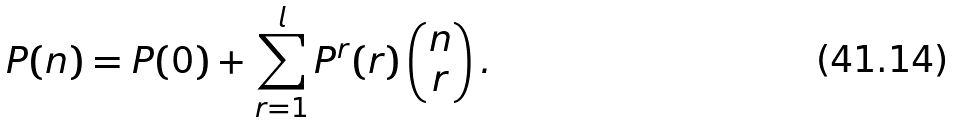Convert formula to latex. <formula><loc_0><loc_0><loc_500><loc_500>P ( n ) = P ( 0 ) + \sum ^ { l } _ { r = 1 } P ^ { r } ( r ) \begin{pmatrix} n \\ r \end{pmatrix} .</formula> 